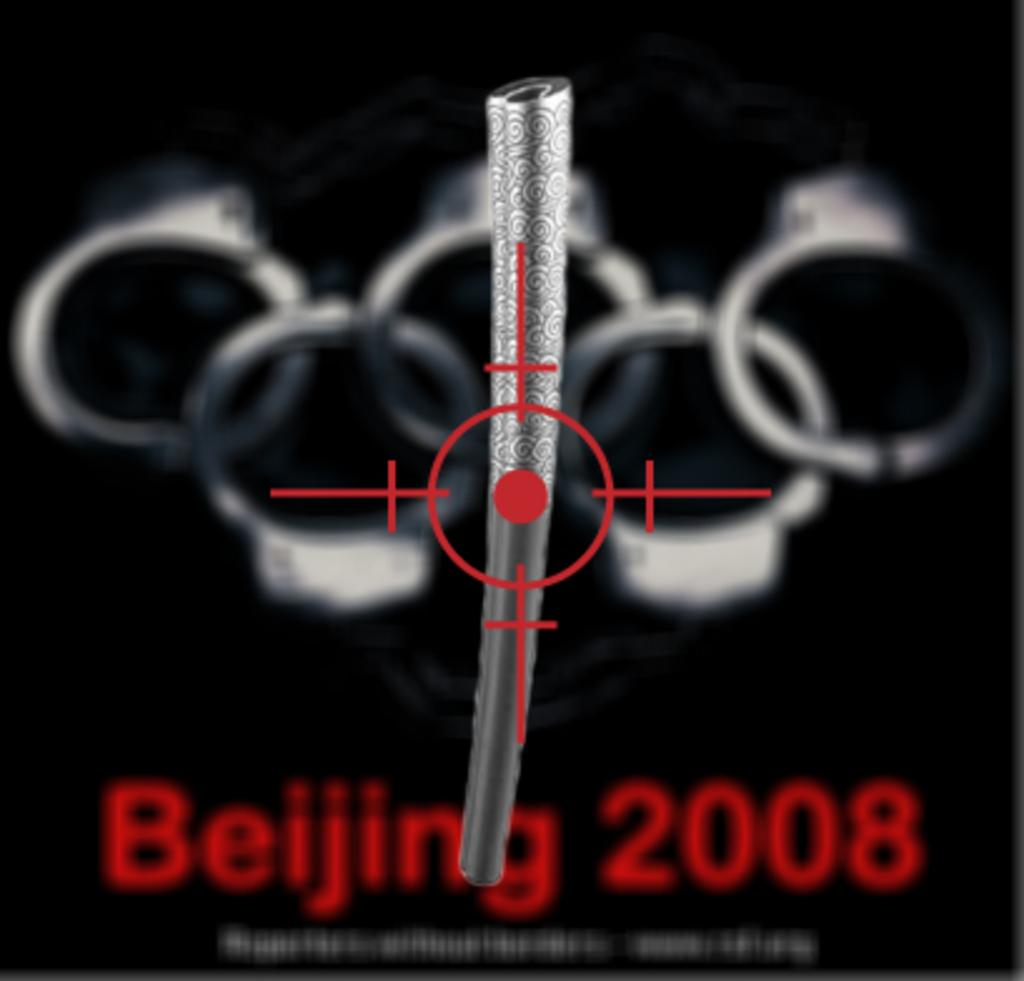<image>
Provide a brief description of the given image. Red Beiging 2008 slogan on a black poster board 